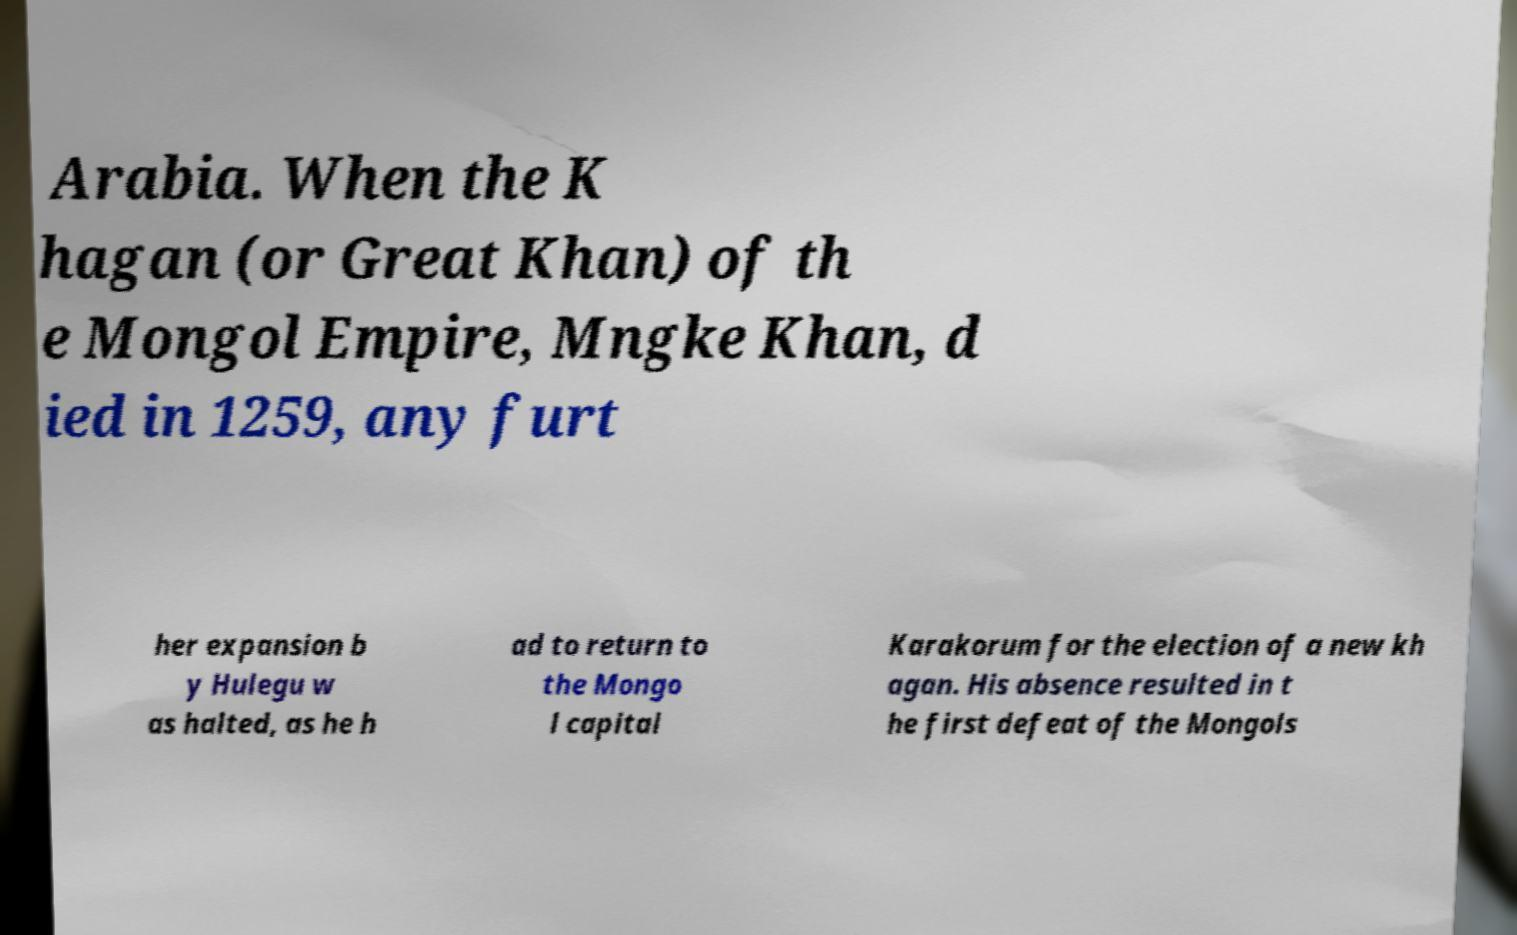Could you extract and type out the text from this image? Arabia. When the K hagan (or Great Khan) of th e Mongol Empire, Mngke Khan, d ied in 1259, any furt her expansion b y Hulegu w as halted, as he h ad to return to the Mongo l capital Karakorum for the election of a new kh agan. His absence resulted in t he first defeat of the Mongols 